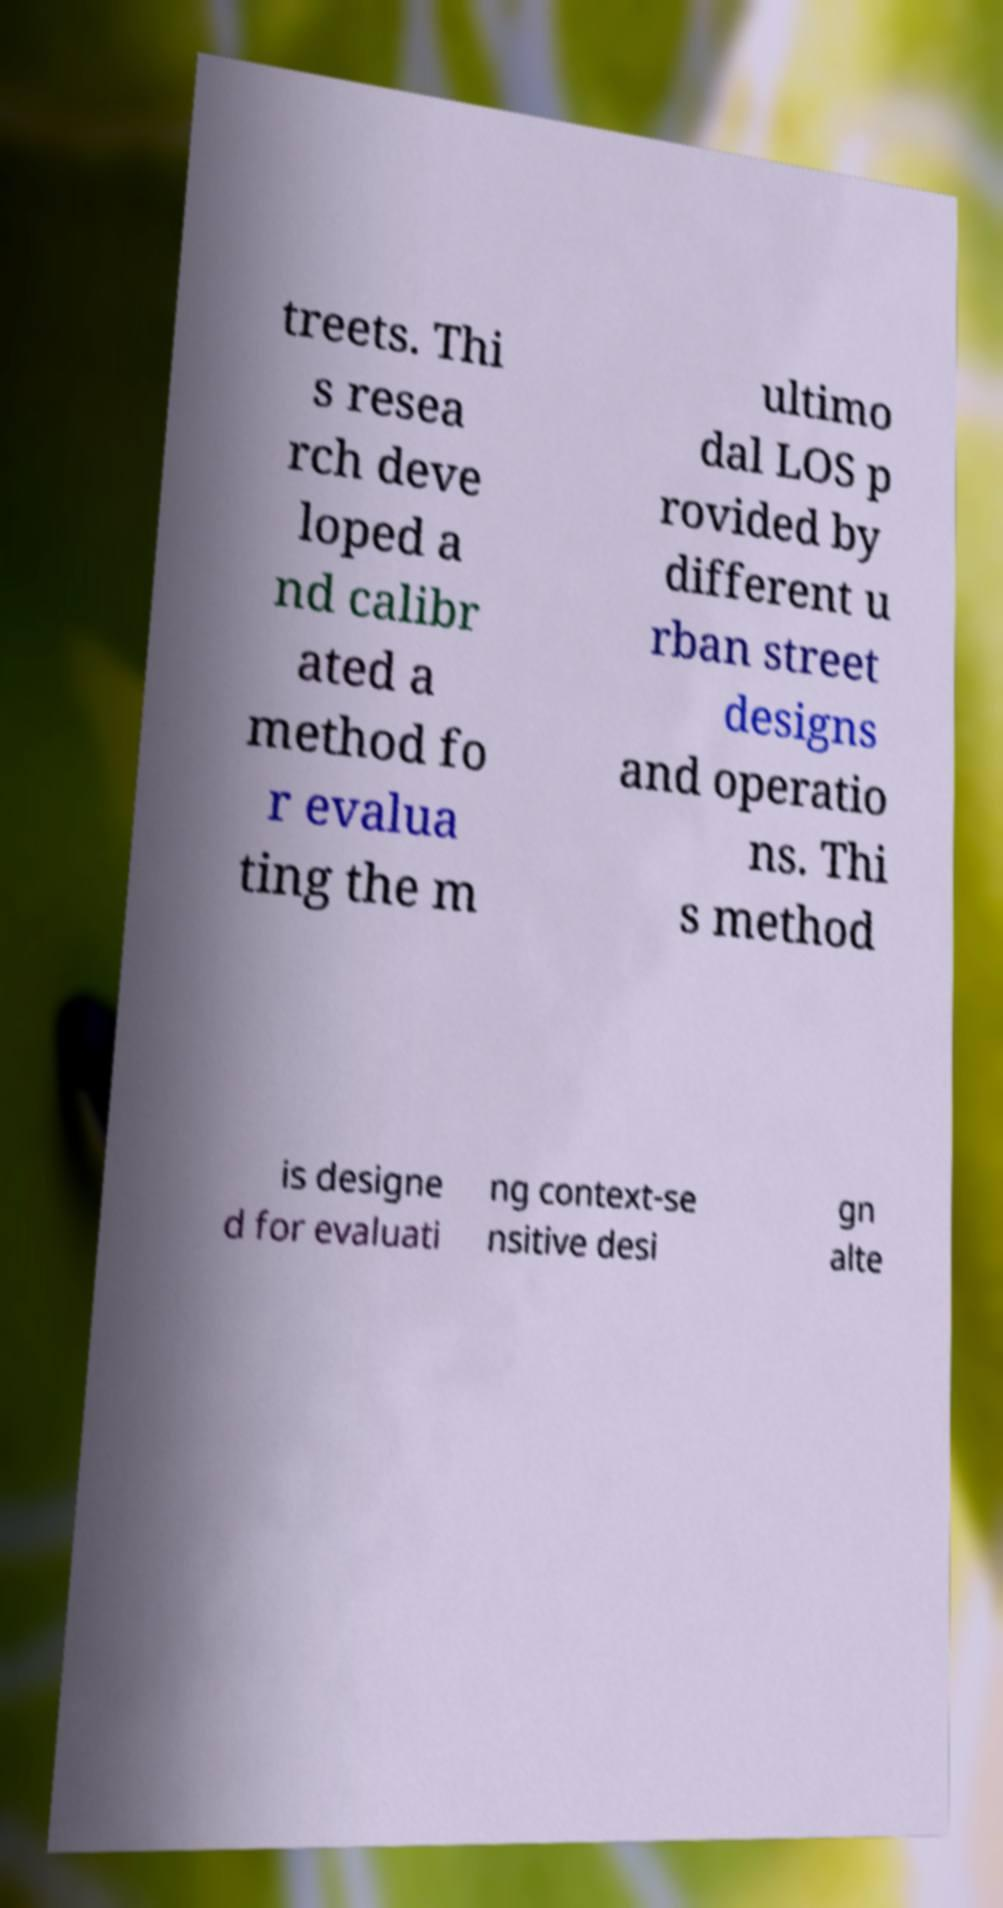Please read and relay the text visible in this image. What does it say? treets. Thi s resea rch deve loped a nd calibr ated a method fo r evalua ting the m ultimo dal LOS p rovided by different u rban street designs and operatio ns. Thi s method is designe d for evaluati ng context-se nsitive desi gn alte 